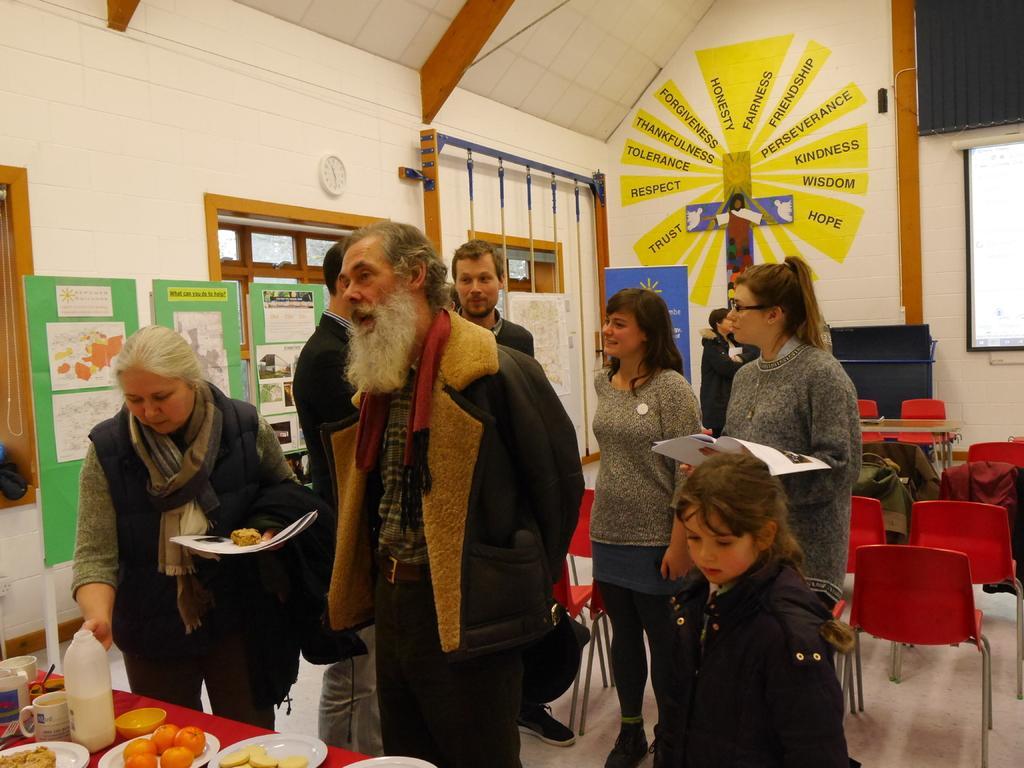Could you give a brief overview of what you see in this image? There is a man standing in the center and talking to someone. In the background there are four people who are standing and the woman here is having a pretty smile on her face. In the background we can see chairs. 